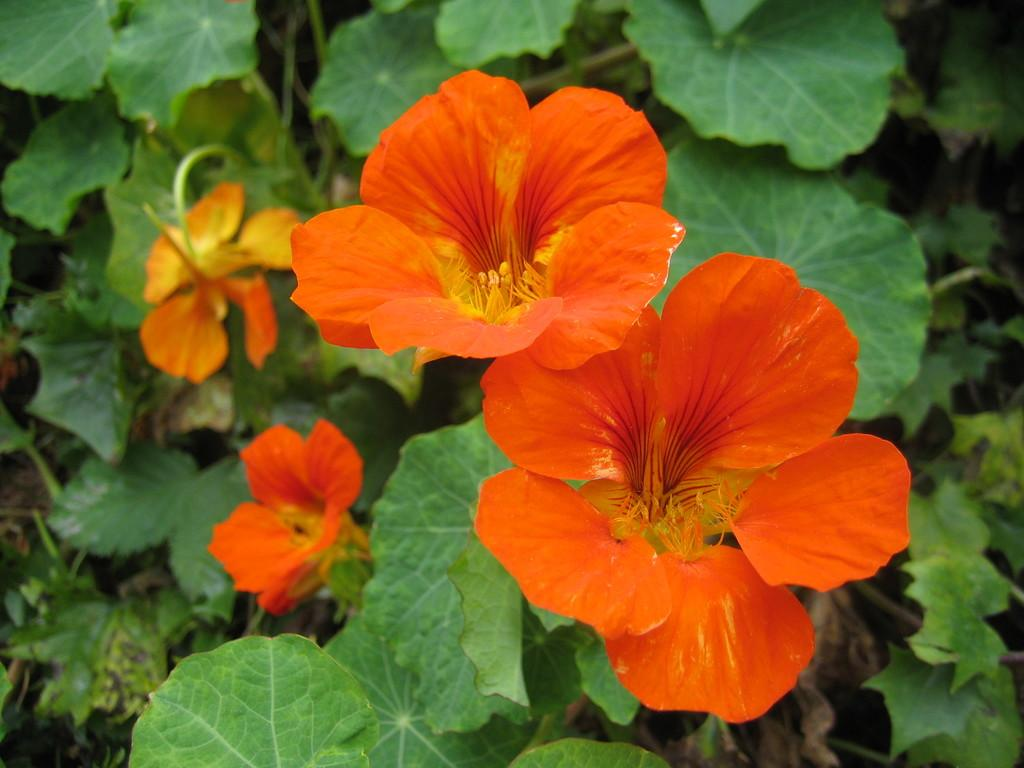What type of plant is visible in the image? There are flowers on a plant in the image. Can you describe the flowers on the plant? Unfortunately, the specific type of flowers cannot be determined from the image alone. What is the primary purpose of the plant in the image? The primary purpose of the plant in the image is to produce and display flowers. What word is written on the mailbox in the image? There is no mailbox present in the image; it only features a plant with flowers. 